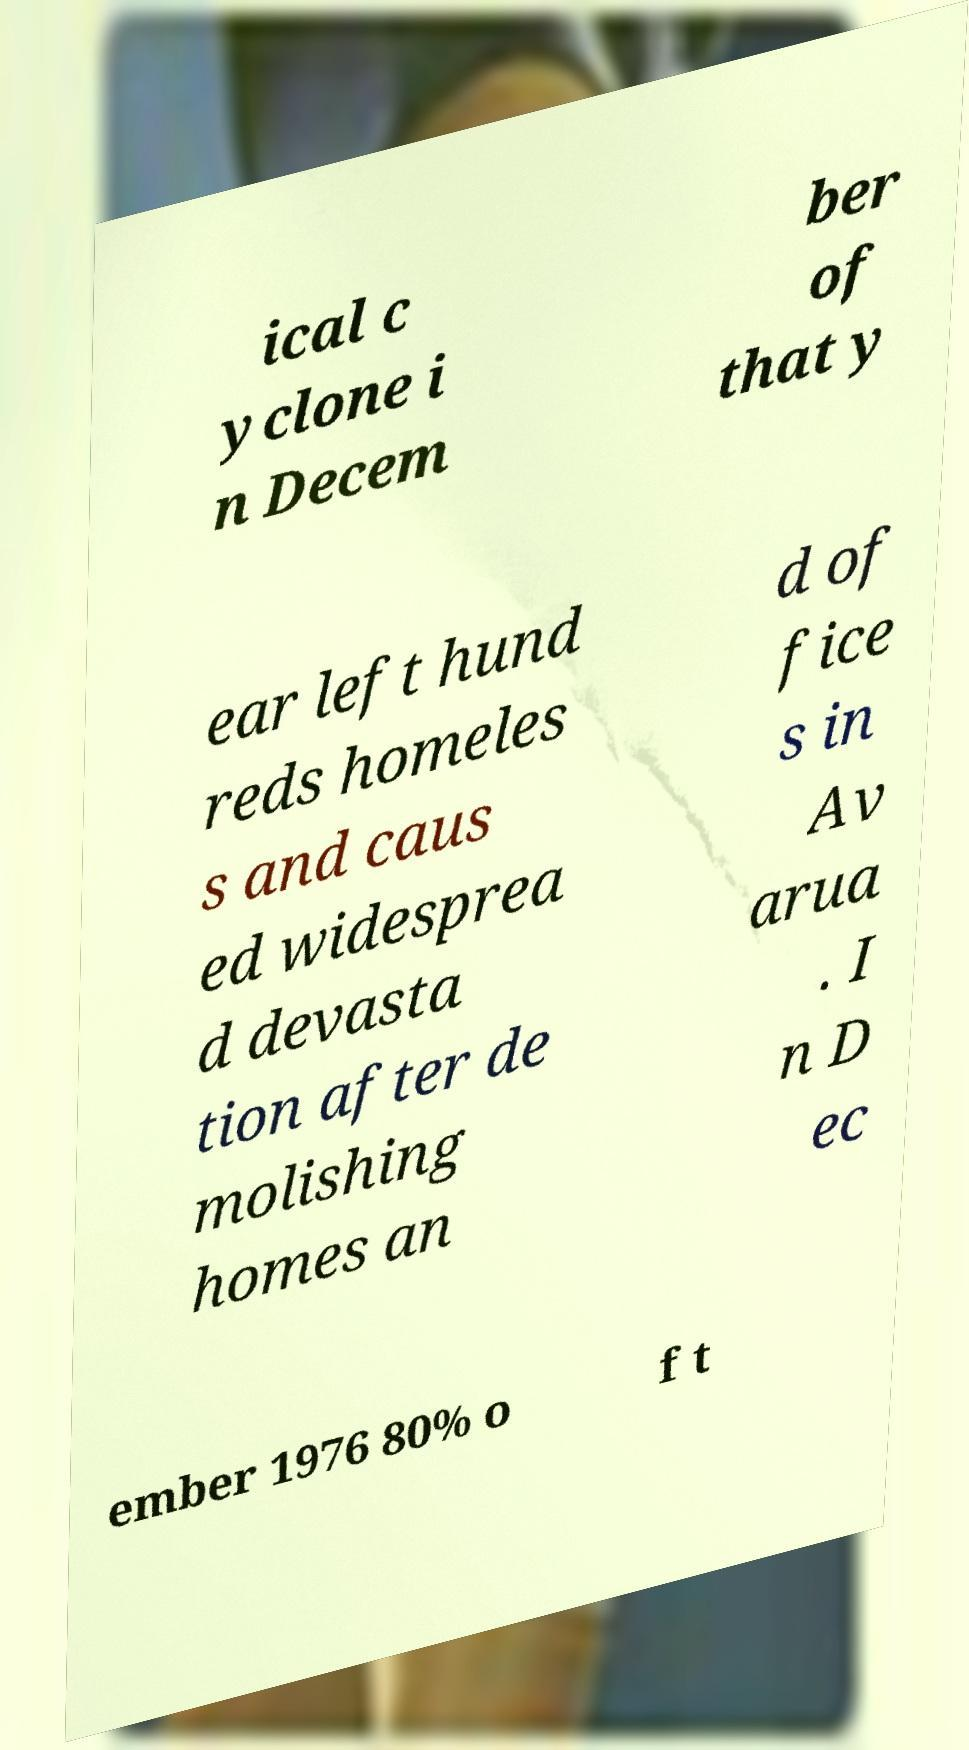What messages or text are displayed in this image? I need them in a readable, typed format. ical c yclone i n Decem ber of that y ear left hund reds homeles s and caus ed widesprea d devasta tion after de molishing homes an d of fice s in Av arua . I n D ec ember 1976 80% o f t 